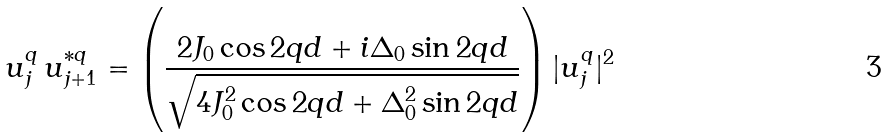<formula> <loc_0><loc_0><loc_500><loc_500>u _ { j } ^ { q } \, u _ { j + 1 } ^ { * q } = \left ( \frac { 2 J _ { 0 } \cos 2 q d + i \Delta _ { 0 } \sin 2 q d } { \sqrt { 4 J _ { 0 } ^ { 2 } \cos 2 q d + \Delta _ { 0 } ^ { 2 } \sin 2 q d } } \right ) | u _ { j } ^ { q } | ^ { 2 }</formula> 